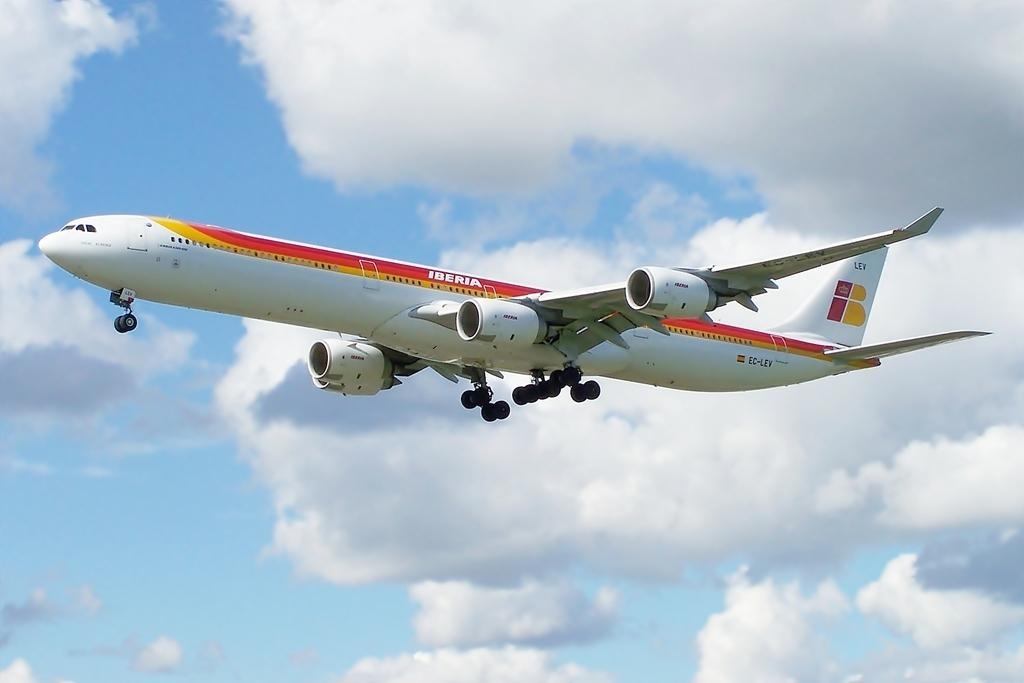What is the main subject of the image? The main subject of the image is an airplane. What colors can be seen on the airplane? The airplane has a color combination of white, red, and yellow. What is the airplane doing in the image? The airplane is flying in the air. What can be seen in the background of the image? There are clouds in the background of the image. What is the color of the sky in the image? The sky is blue in the image. What type of jail can be seen in the image? There is no jail present in the image; it features an airplane flying in the sky. What kind of magic is being performed by the airplane in the image? There is no magic being performed by the airplane in the image; it is simply flying in the air. 